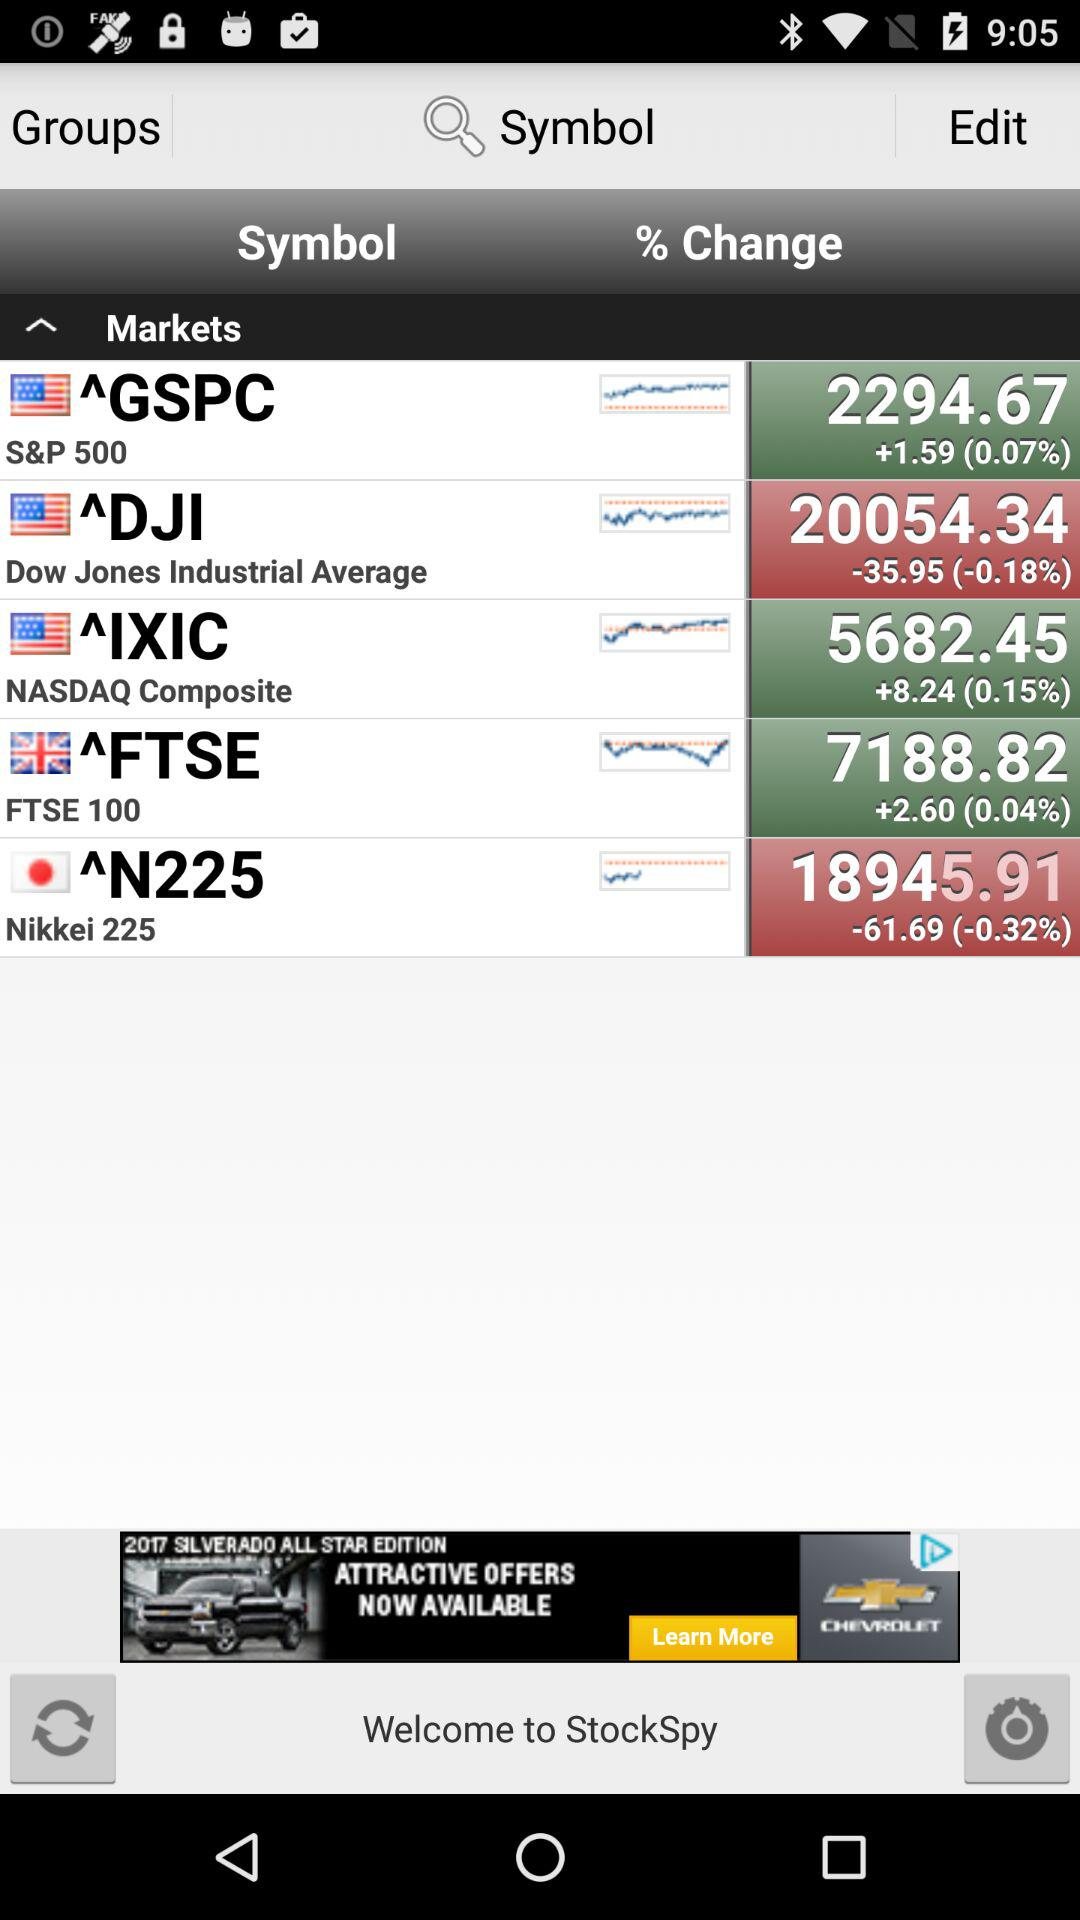What is the decreasing rate of the DJI? The decreasing rate is -0.18%. 